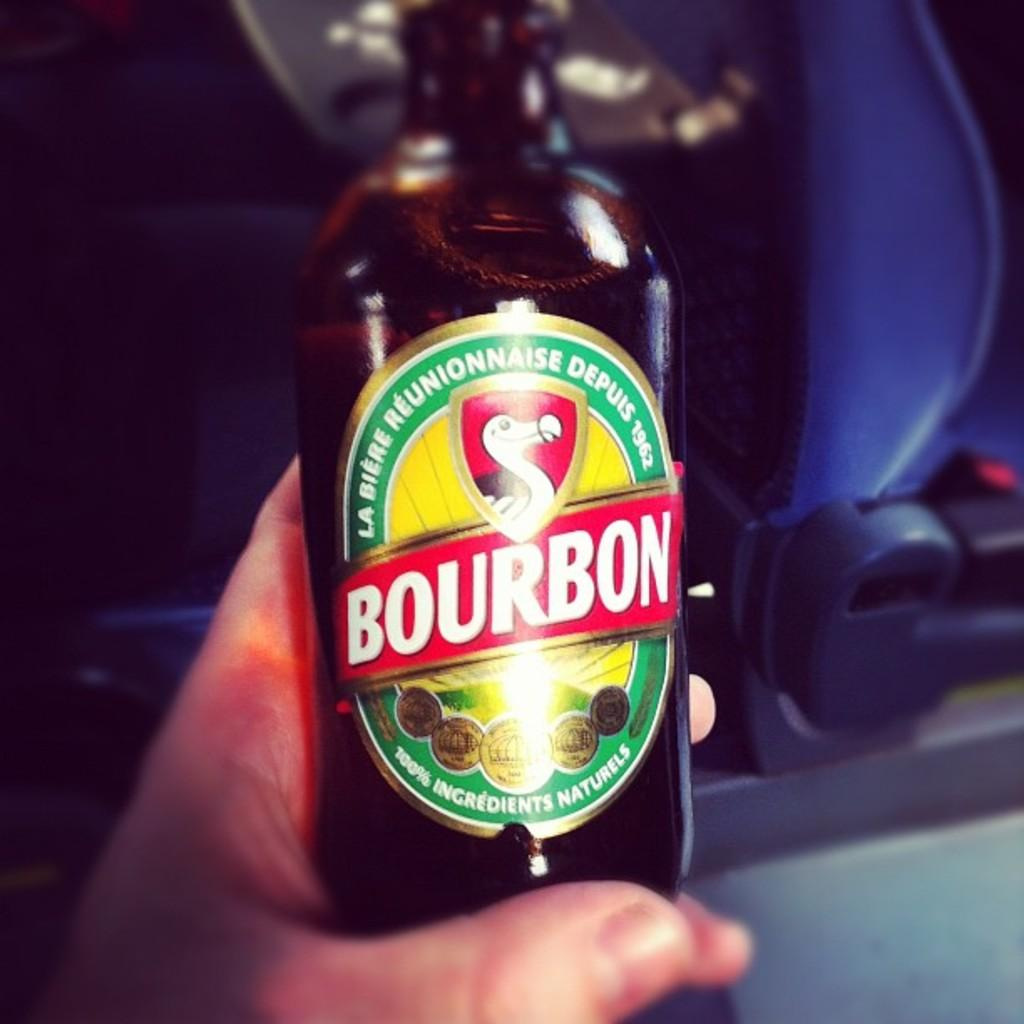<image>
Relay a brief, clear account of the picture shown. A bottle of alcohol has the word Bourbon on its label. 